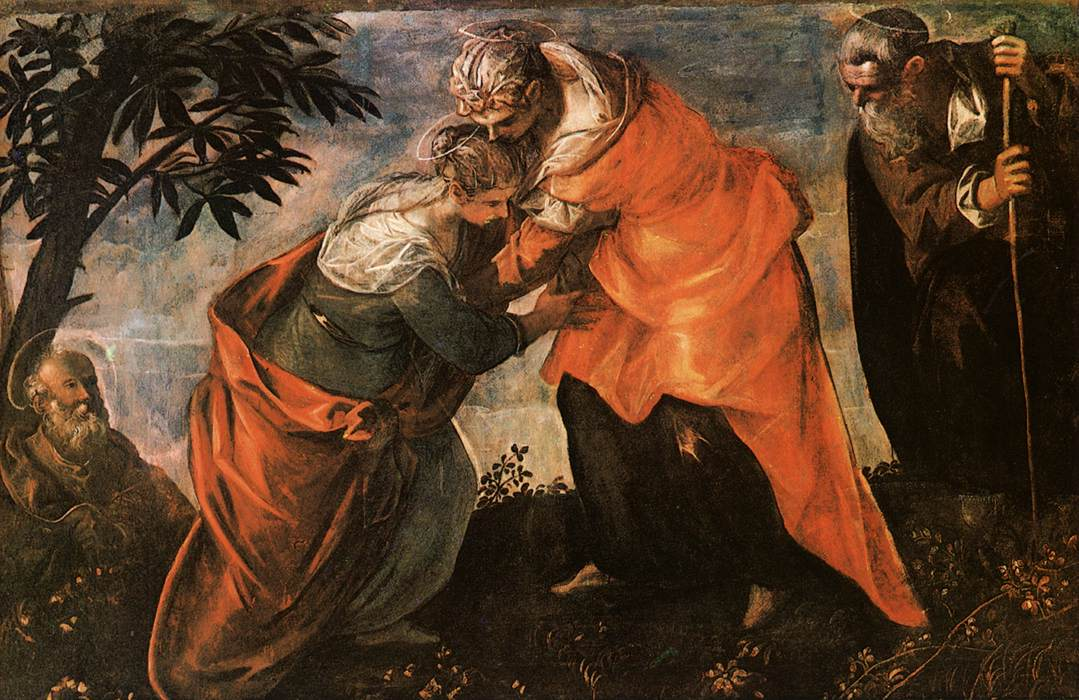Can you elaborate on the historical and cultural significance of the Visitation event depicted here? The Visitation is a pivotal event in Christian tradition, recorded in the Gospel of Luke. It describes the visit of the Virgin Mary to her cousin Elizabeth, both of whom were miraculously expecting children. Mary was pregnant with Jesus, while Elizabeth was carrying John the Baptist. This meeting is considered significant because it highlights the recognition of Jesus as the Messiah even before his birth. When Mary greeted Elizabeth, the baby in Elizabeth's womb leapt for joy, and Elizabeth proclaimed her cousin blessed among women, thus setting a tone of divine purpose and joy. Artists during the Renaissance cherished these narratives, using them as profound expressions of faith and human connection rendered through their mastery of realistic representation. 